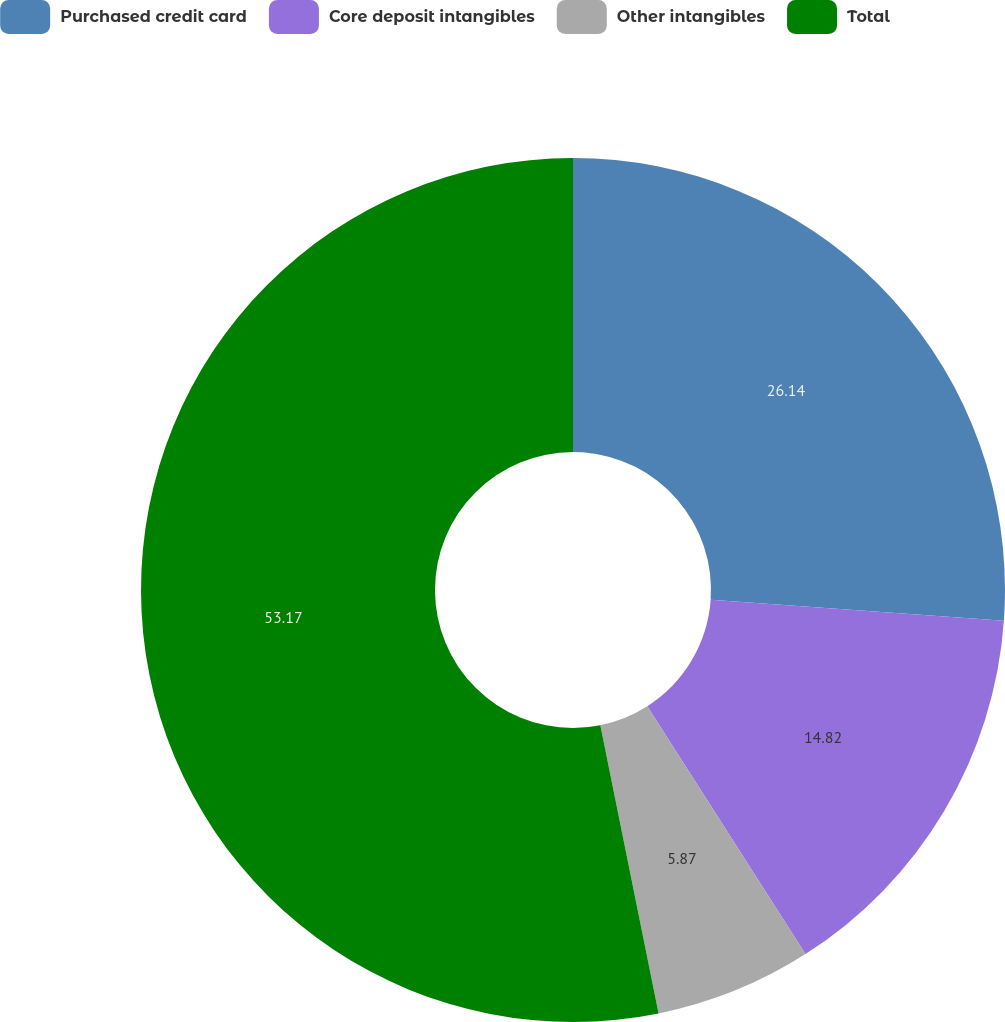Convert chart. <chart><loc_0><loc_0><loc_500><loc_500><pie_chart><fcel>Purchased credit card<fcel>Core deposit intangibles<fcel>Other intangibles<fcel>Total<nl><fcel>26.14%<fcel>14.82%<fcel>5.87%<fcel>53.18%<nl></chart> 